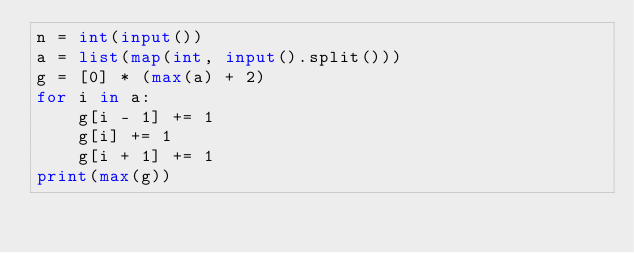Convert code to text. <code><loc_0><loc_0><loc_500><loc_500><_Python_>n = int(input())
a = list(map(int, input().split()))
g = [0] * (max(a) + 2)
for i in a:
    g[i - 1] += 1
    g[i] += 1
    g[i + 1] += 1
print(max(g))</code> 